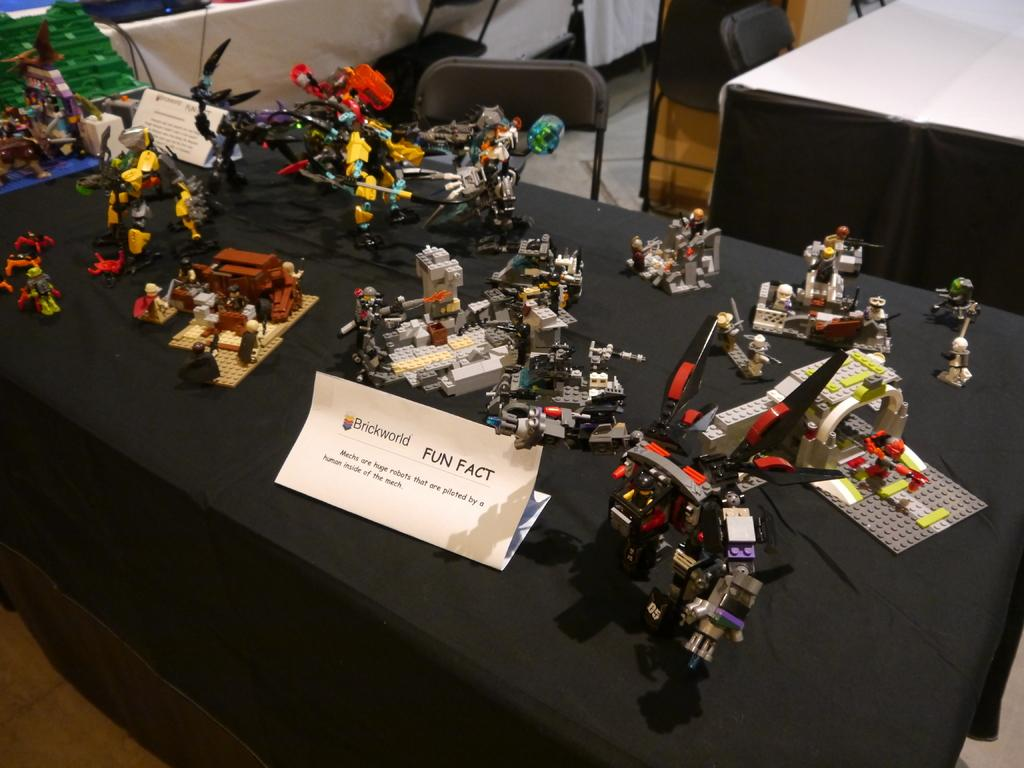What objects can be seen on the table in the image? There are toys and boards on the table. Are there any other items on the table besides toys and boards? Yes, there are other things on the table. What type of furniture is located beside the table? There are chairs beside the table. What type of shoe is visible in the image? There is no shoe present in the image. Can you describe the sky in the image? The provided facts do not mention the sky, so we cannot describe it. 